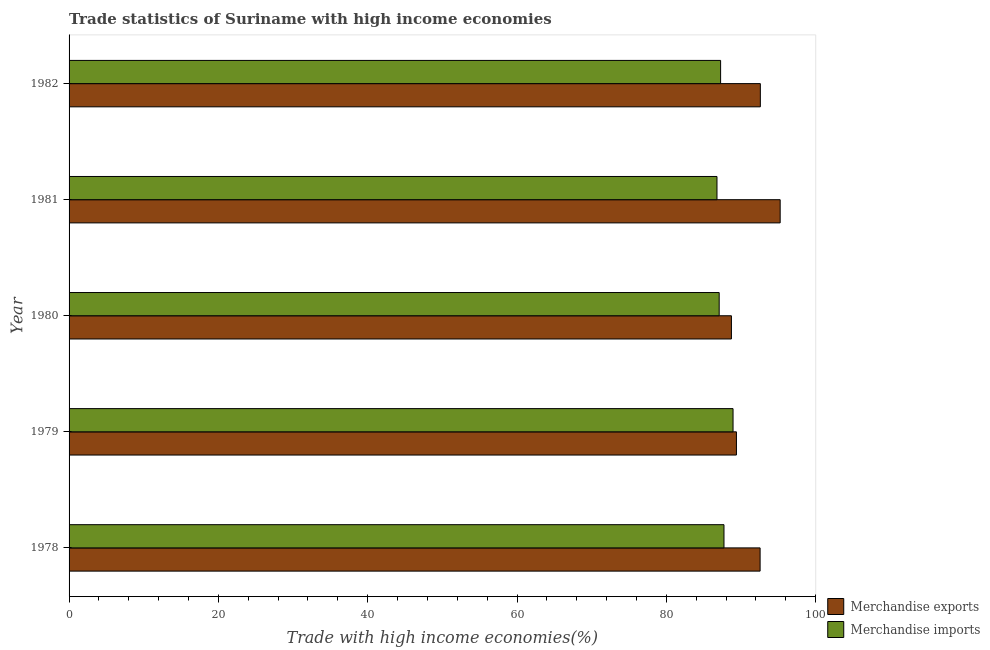How many different coloured bars are there?
Your answer should be compact. 2. How many groups of bars are there?
Give a very brief answer. 5. Are the number of bars per tick equal to the number of legend labels?
Ensure brevity in your answer.  Yes. How many bars are there on the 4th tick from the top?
Offer a very short reply. 2. How many bars are there on the 5th tick from the bottom?
Give a very brief answer. 2. In how many cases, is the number of bars for a given year not equal to the number of legend labels?
Offer a terse response. 0. What is the merchandise imports in 1981?
Give a very brief answer. 86.78. Across all years, what is the maximum merchandise imports?
Give a very brief answer. 88.93. Across all years, what is the minimum merchandise exports?
Make the answer very short. 88.72. In which year was the merchandise imports maximum?
Keep it short and to the point. 1979. What is the total merchandise exports in the graph?
Give a very brief answer. 458.5. What is the difference between the merchandise exports in 1978 and that in 1981?
Give a very brief answer. -2.69. What is the difference between the merchandise imports in 1979 and the merchandise exports in 1980?
Your answer should be very brief. 0.22. What is the average merchandise imports per year?
Offer a terse response. 87.56. In the year 1982, what is the difference between the merchandise exports and merchandise imports?
Keep it short and to the point. 5.32. In how many years, is the merchandise imports greater than 64 %?
Give a very brief answer. 5. Is the merchandise imports in 1979 less than that in 1982?
Provide a succinct answer. No. What is the difference between the highest and the second highest merchandise exports?
Offer a very short reply. 2.66. What is the difference between the highest and the lowest merchandise exports?
Provide a short and direct response. 6.53. In how many years, is the merchandise imports greater than the average merchandise imports taken over all years?
Your answer should be compact. 2. What does the 2nd bar from the bottom in 1980 represents?
Provide a short and direct response. Merchandise imports. How many bars are there?
Keep it short and to the point. 10. What is the difference between two consecutive major ticks on the X-axis?
Offer a very short reply. 20. Does the graph contain any zero values?
Your answer should be very brief. No. Does the graph contain grids?
Your answer should be compact. No. Where does the legend appear in the graph?
Make the answer very short. Bottom right. How are the legend labels stacked?
Your answer should be compact. Vertical. What is the title of the graph?
Your response must be concise. Trade statistics of Suriname with high income economies. Does "Official aid received" appear as one of the legend labels in the graph?
Ensure brevity in your answer.  No. What is the label or title of the X-axis?
Your answer should be very brief. Trade with high income economies(%). What is the label or title of the Y-axis?
Offer a very short reply. Year. What is the Trade with high income economies(%) of Merchandise exports in 1978?
Make the answer very short. 92.56. What is the Trade with high income economies(%) of Merchandise imports in 1978?
Offer a very short reply. 87.72. What is the Trade with high income economies(%) in Merchandise exports in 1979?
Provide a succinct answer. 89.39. What is the Trade with high income economies(%) of Merchandise imports in 1979?
Provide a short and direct response. 88.93. What is the Trade with high income economies(%) in Merchandise exports in 1980?
Offer a very short reply. 88.72. What is the Trade with high income economies(%) of Merchandise imports in 1980?
Provide a short and direct response. 87.08. What is the Trade with high income economies(%) in Merchandise exports in 1981?
Your response must be concise. 95.25. What is the Trade with high income economies(%) of Merchandise imports in 1981?
Make the answer very short. 86.78. What is the Trade with high income economies(%) in Merchandise exports in 1982?
Your answer should be compact. 92.59. What is the Trade with high income economies(%) of Merchandise imports in 1982?
Ensure brevity in your answer.  87.27. Across all years, what is the maximum Trade with high income economies(%) of Merchandise exports?
Your answer should be very brief. 95.25. Across all years, what is the maximum Trade with high income economies(%) of Merchandise imports?
Ensure brevity in your answer.  88.93. Across all years, what is the minimum Trade with high income economies(%) in Merchandise exports?
Offer a very short reply. 88.72. Across all years, what is the minimum Trade with high income economies(%) of Merchandise imports?
Keep it short and to the point. 86.78. What is the total Trade with high income economies(%) of Merchandise exports in the graph?
Keep it short and to the point. 458.5. What is the total Trade with high income economies(%) in Merchandise imports in the graph?
Your answer should be compact. 437.78. What is the difference between the Trade with high income economies(%) in Merchandise exports in 1978 and that in 1979?
Provide a short and direct response. 3.17. What is the difference between the Trade with high income economies(%) in Merchandise imports in 1978 and that in 1979?
Ensure brevity in your answer.  -1.21. What is the difference between the Trade with high income economies(%) in Merchandise exports in 1978 and that in 1980?
Give a very brief answer. 3.84. What is the difference between the Trade with high income economies(%) in Merchandise imports in 1978 and that in 1980?
Your answer should be compact. 0.64. What is the difference between the Trade with high income economies(%) of Merchandise exports in 1978 and that in 1981?
Your response must be concise. -2.69. What is the difference between the Trade with high income economies(%) of Merchandise imports in 1978 and that in 1981?
Your answer should be compact. 0.94. What is the difference between the Trade with high income economies(%) of Merchandise exports in 1978 and that in 1982?
Ensure brevity in your answer.  -0.03. What is the difference between the Trade with high income economies(%) of Merchandise imports in 1978 and that in 1982?
Ensure brevity in your answer.  0.45. What is the difference between the Trade with high income economies(%) in Merchandise exports in 1979 and that in 1980?
Make the answer very short. 0.67. What is the difference between the Trade with high income economies(%) of Merchandise imports in 1979 and that in 1980?
Provide a succinct answer. 1.86. What is the difference between the Trade with high income economies(%) in Merchandise exports in 1979 and that in 1981?
Your answer should be very brief. -5.86. What is the difference between the Trade with high income economies(%) of Merchandise imports in 1979 and that in 1981?
Make the answer very short. 2.15. What is the difference between the Trade with high income economies(%) of Merchandise exports in 1979 and that in 1982?
Offer a terse response. -3.2. What is the difference between the Trade with high income economies(%) of Merchandise imports in 1979 and that in 1982?
Your answer should be very brief. 1.66. What is the difference between the Trade with high income economies(%) of Merchandise exports in 1980 and that in 1981?
Give a very brief answer. -6.53. What is the difference between the Trade with high income economies(%) of Merchandise imports in 1980 and that in 1981?
Keep it short and to the point. 0.29. What is the difference between the Trade with high income economies(%) in Merchandise exports in 1980 and that in 1982?
Give a very brief answer. -3.87. What is the difference between the Trade with high income economies(%) of Merchandise imports in 1980 and that in 1982?
Your response must be concise. -0.19. What is the difference between the Trade with high income economies(%) of Merchandise exports in 1981 and that in 1982?
Offer a terse response. 2.66. What is the difference between the Trade with high income economies(%) in Merchandise imports in 1981 and that in 1982?
Keep it short and to the point. -0.49. What is the difference between the Trade with high income economies(%) in Merchandise exports in 1978 and the Trade with high income economies(%) in Merchandise imports in 1979?
Offer a terse response. 3.63. What is the difference between the Trade with high income economies(%) of Merchandise exports in 1978 and the Trade with high income economies(%) of Merchandise imports in 1980?
Your response must be concise. 5.48. What is the difference between the Trade with high income economies(%) in Merchandise exports in 1978 and the Trade with high income economies(%) in Merchandise imports in 1981?
Give a very brief answer. 5.78. What is the difference between the Trade with high income economies(%) of Merchandise exports in 1978 and the Trade with high income economies(%) of Merchandise imports in 1982?
Your answer should be compact. 5.29. What is the difference between the Trade with high income economies(%) in Merchandise exports in 1979 and the Trade with high income economies(%) in Merchandise imports in 1980?
Keep it short and to the point. 2.31. What is the difference between the Trade with high income economies(%) of Merchandise exports in 1979 and the Trade with high income economies(%) of Merchandise imports in 1981?
Keep it short and to the point. 2.6. What is the difference between the Trade with high income economies(%) of Merchandise exports in 1979 and the Trade with high income economies(%) of Merchandise imports in 1982?
Give a very brief answer. 2.12. What is the difference between the Trade with high income economies(%) of Merchandise exports in 1980 and the Trade with high income economies(%) of Merchandise imports in 1981?
Provide a succinct answer. 1.93. What is the difference between the Trade with high income economies(%) in Merchandise exports in 1980 and the Trade with high income economies(%) in Merchandise imports in 1982?
Your response must be concise. 1.45. What is the difference between the Trade with high income economies(%) of Merchandise exports in 1981 and the Trade with high income economies(%) of Merchandise imports in 1982?
Provide a short and direct response. 7.98. What is the average Trade with high income economies(%) of Merchandise exports per year?
Provide a succinct answer. 91.7. What is the average Trade with high income economies(%) of Merchandise imports per year?
Ensure brevity in your answer.  87.56. In the year 1978, what is the difference between the Trade with high income economies(%) in Merchandise exports and Trade with high income economies(%) in Merchandise imports?
Offer a terse response. 4.84. In the year 1979, what is the difference between the Trade with high income economies(%) of Merchandise exports and Trade with high income economies(%) of Merchandise imports?
Your answer should be compact. 0.46. In the year 1980, what is the difference between the Trade with high income economies(%) of Merchandise exports and Trade with high income economies(%) of Merchandise imports?
Offer a terse response. 1.64. In the year 1981, what is the difference between the Trade with high income economies(%) of Merchandise exports and Trade with high income economies(%) of Merchandise imports?
Offer a terse response. 8.46. In the year 1982, what is the difference between the Trade with high income economies(%) in Merchandise exports and Trade with high income economies(%) in Merchandise imports?
Your answer should be compact. 5.32. What is the ratio of the Trade with high income economies(%) in Merchandise exports in 1978 to that in 1979?
Offer a very short reply. 1.04. What is the ratio of the Trade with high income economies(%) in Merchandise imports in 1978 to that in 1979?
Ensure brevity in your answer.  0.99. What is the ratio of the Trade with high income economies(%) of Merchandise exports in 1978 to that in 1980?
Your answer should be very brief. 1.04. What is the ratio of the Trade with high income economies(%) of Merchandise imports in 1978 to that in 1980?
Give a very brief answer. 1.01. What is the ratio of the Trade with high income economies(%) in Merchandise exports in 1978 to that in 1981?
Your answer should be compact. 0.97. What is the ratio of the Trade with high income economies(%) in Merchandise imports in 1978 to that in 1981?
Provide a short and direct response. 1.01. What is the ratio of the Trade with high income economies(%) in Merchandise exports in 1978 to that in 1982?
Make the answer very short. 1. What is the ratio of the Trade with high income economies(%) of Merchandise exports in 1979 to that in 1980?
Offer a very short reply. 1.01. What is the ratio of the Trade with high income economies(%) in Merchandise imports in 1979 to that in 1980?
Make the answer very short. 1.02. What is the ratio of the Trade with high income economies(%) of Merchandise exports in 1979 to that in 1981?
Offer a terse response. 0.94. What is the ratio of the Trade with high income economies(%) in Merchandise imports in 1979 to that in 1981?
Offer a very short reply. 1.02. What is the ratio of the Trade with high income economies(%) of Merchandise exports in 1979 to that in 1982?
Keep it short and to the point. 0.97. What is the ratio of the Trade with high income economies(%) in Merchandise imports in 1979 to that in 1982?
Give a very brief answer. 1.02. What is the ratio of the Trade with high income economies(%) of Merchandise exports in 1980 to that in 1981?
Your answer should be very brief. 0.93. What is the ratio of the Trade with high income economies(%) of Merchandise imports in 1980 to that in 1981?
Offer a very short reply. 1. What is the ratio of the Trade with high income economies(%) in Merchandise exports in 1980 to that in 1982?
Offer a very short reply. 0.96. What is the ratio of the Trade with high income economies(%) of Merchandise exports in 1981 to that in 1982?
Provide a short and direct response. 1.03. What is the ratio of the Trade with high income economies(%) of Merchandise imports in 1981 to that in 1982?
Your response must be concise. 0.99. What is the difference between the highest and the second highest Trade with high income economies(%) of Merchandise exports?
Ensure brevity in your answer.  2.66. What is the difference between the highest and the second highest Trade with high income economies(%) of Merchandise imports?
Keep it short and to the point. 1.21. What is the difference between the highest and the lowest Trade with high income economies(%) of Merchandise exports?
Ensure brevity in your answer.  6.53. What is the difference between the highest and the lowest Trade with high income economies(%) in Merchandise imports?
Your response must be concise. 2.15. 